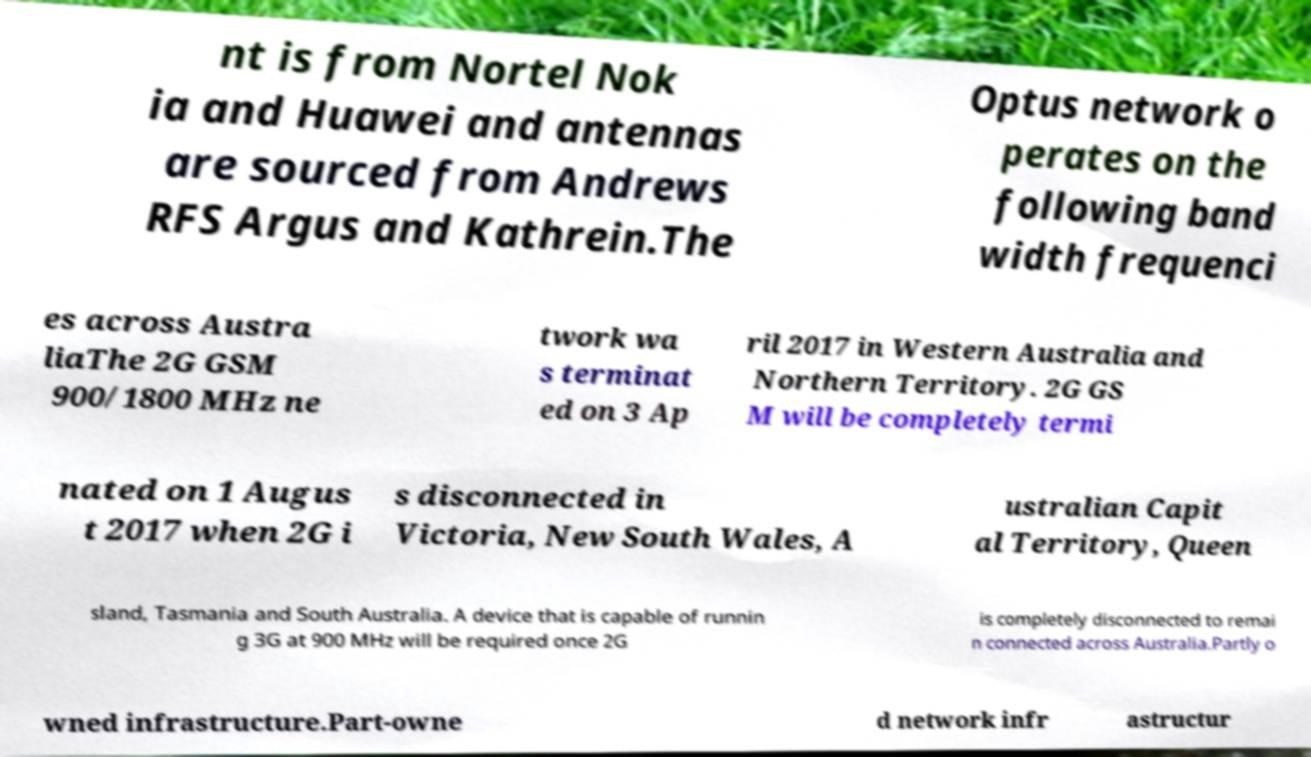Can you read and provide the text displayed in the image?This photo seems to have some interesting text. Can you extract and type it out for me? nt is from Nortel Nok ia and Huawei and antennas are sourced from Andrews RFS Argus and Kathrein.The Optus network o perates on the following band width frequenci es across Austra liaThe 2G GSM 900/1800 MHz ne twork wa s terminat ed on 3 Ap ril 2017 in Western Australia and Northern Territory. 2G GS M will be completely termi nated on 1 Augus t 2017 when 2G i s disconnected in Victoria, New South Wales, A ustralian Capit al Territory, Queen sland, Tasmania and South Australia. A device that is capable of runnin g 3G at 900 MHz will be required once 2G is completely disconnected to remai n connected across Australia.Partly o wned infrastructure.Part-owne d network infr astructur 